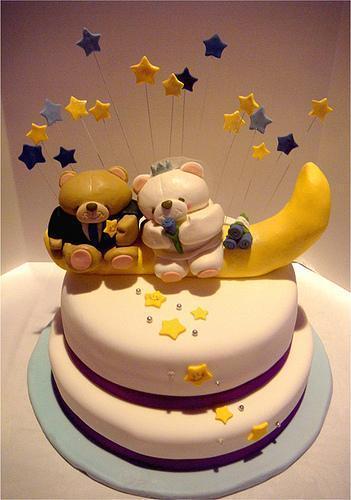How many bears are in the picture?
Give a very brief answer. 2. 